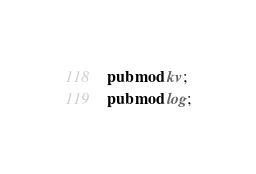<code> <loc_0><loc_0><loc_500><loc_500><_Rust_>pub mod kv;
pub mod log;</code> 